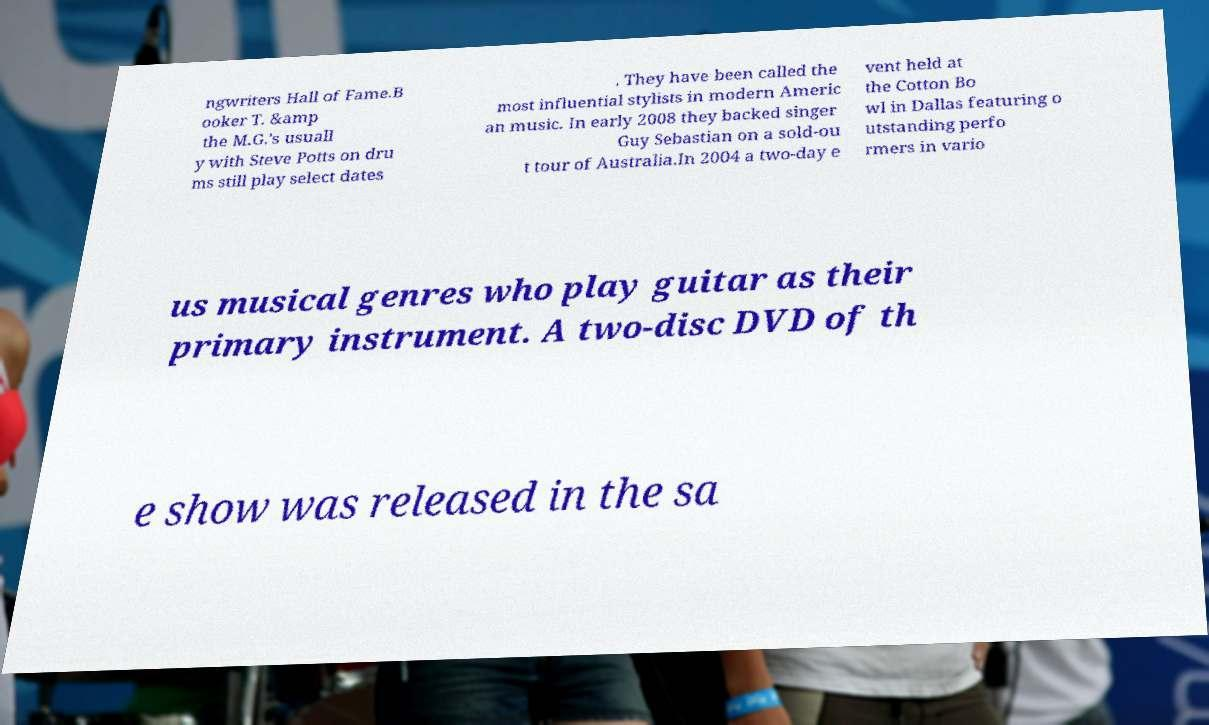For documentation purposes, I need the text within this image transcribed. Could you provide that? ngwriters Hall of Fame.B ooker T. &amp the M.G.'s usuall y with Steve Potts on dru ms still play select dates . They have been called the most influential stylists in modern Americ an music. In early 2008 they backed singer Guy Sebastian on a sold-ou t tour of Australia.In 2004 a two-day e vent held at the Cotton Bo wl in Dallas featuring o utstanding perfo rmers in vario us musical genres who play guitar as their primary instrument. A two-disc DVD of th e show was released in the sa 